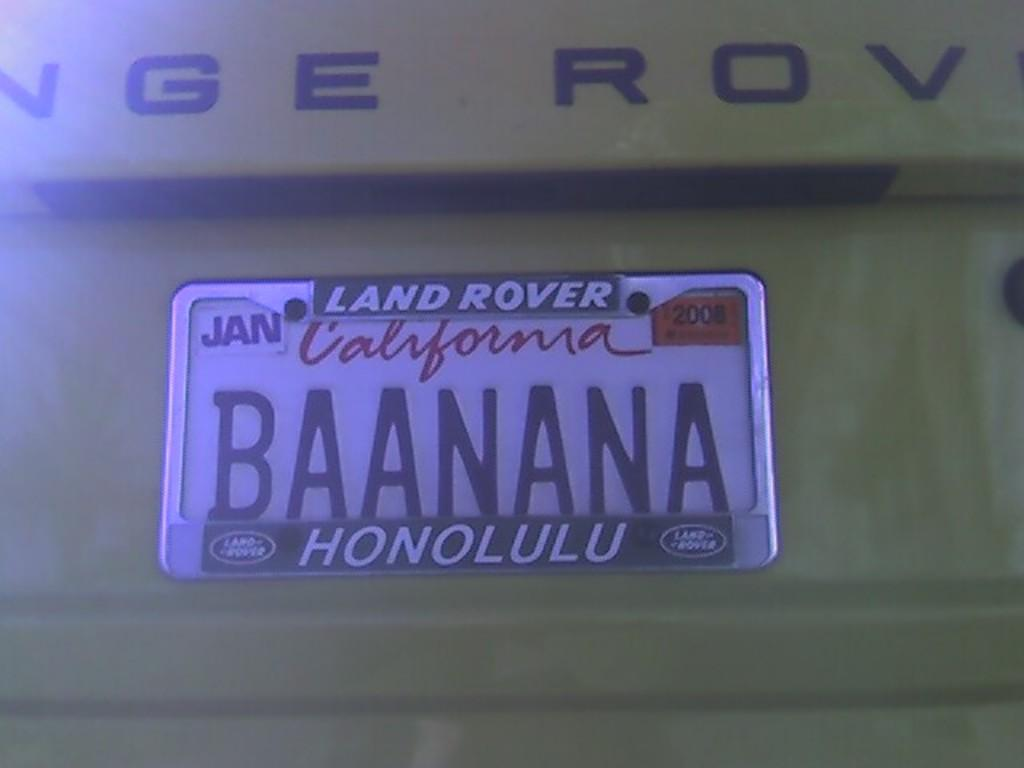<image>
Create a compact narrative representing the image presented. A yellow Land Rover with a California tag that says BAANANA on it. 